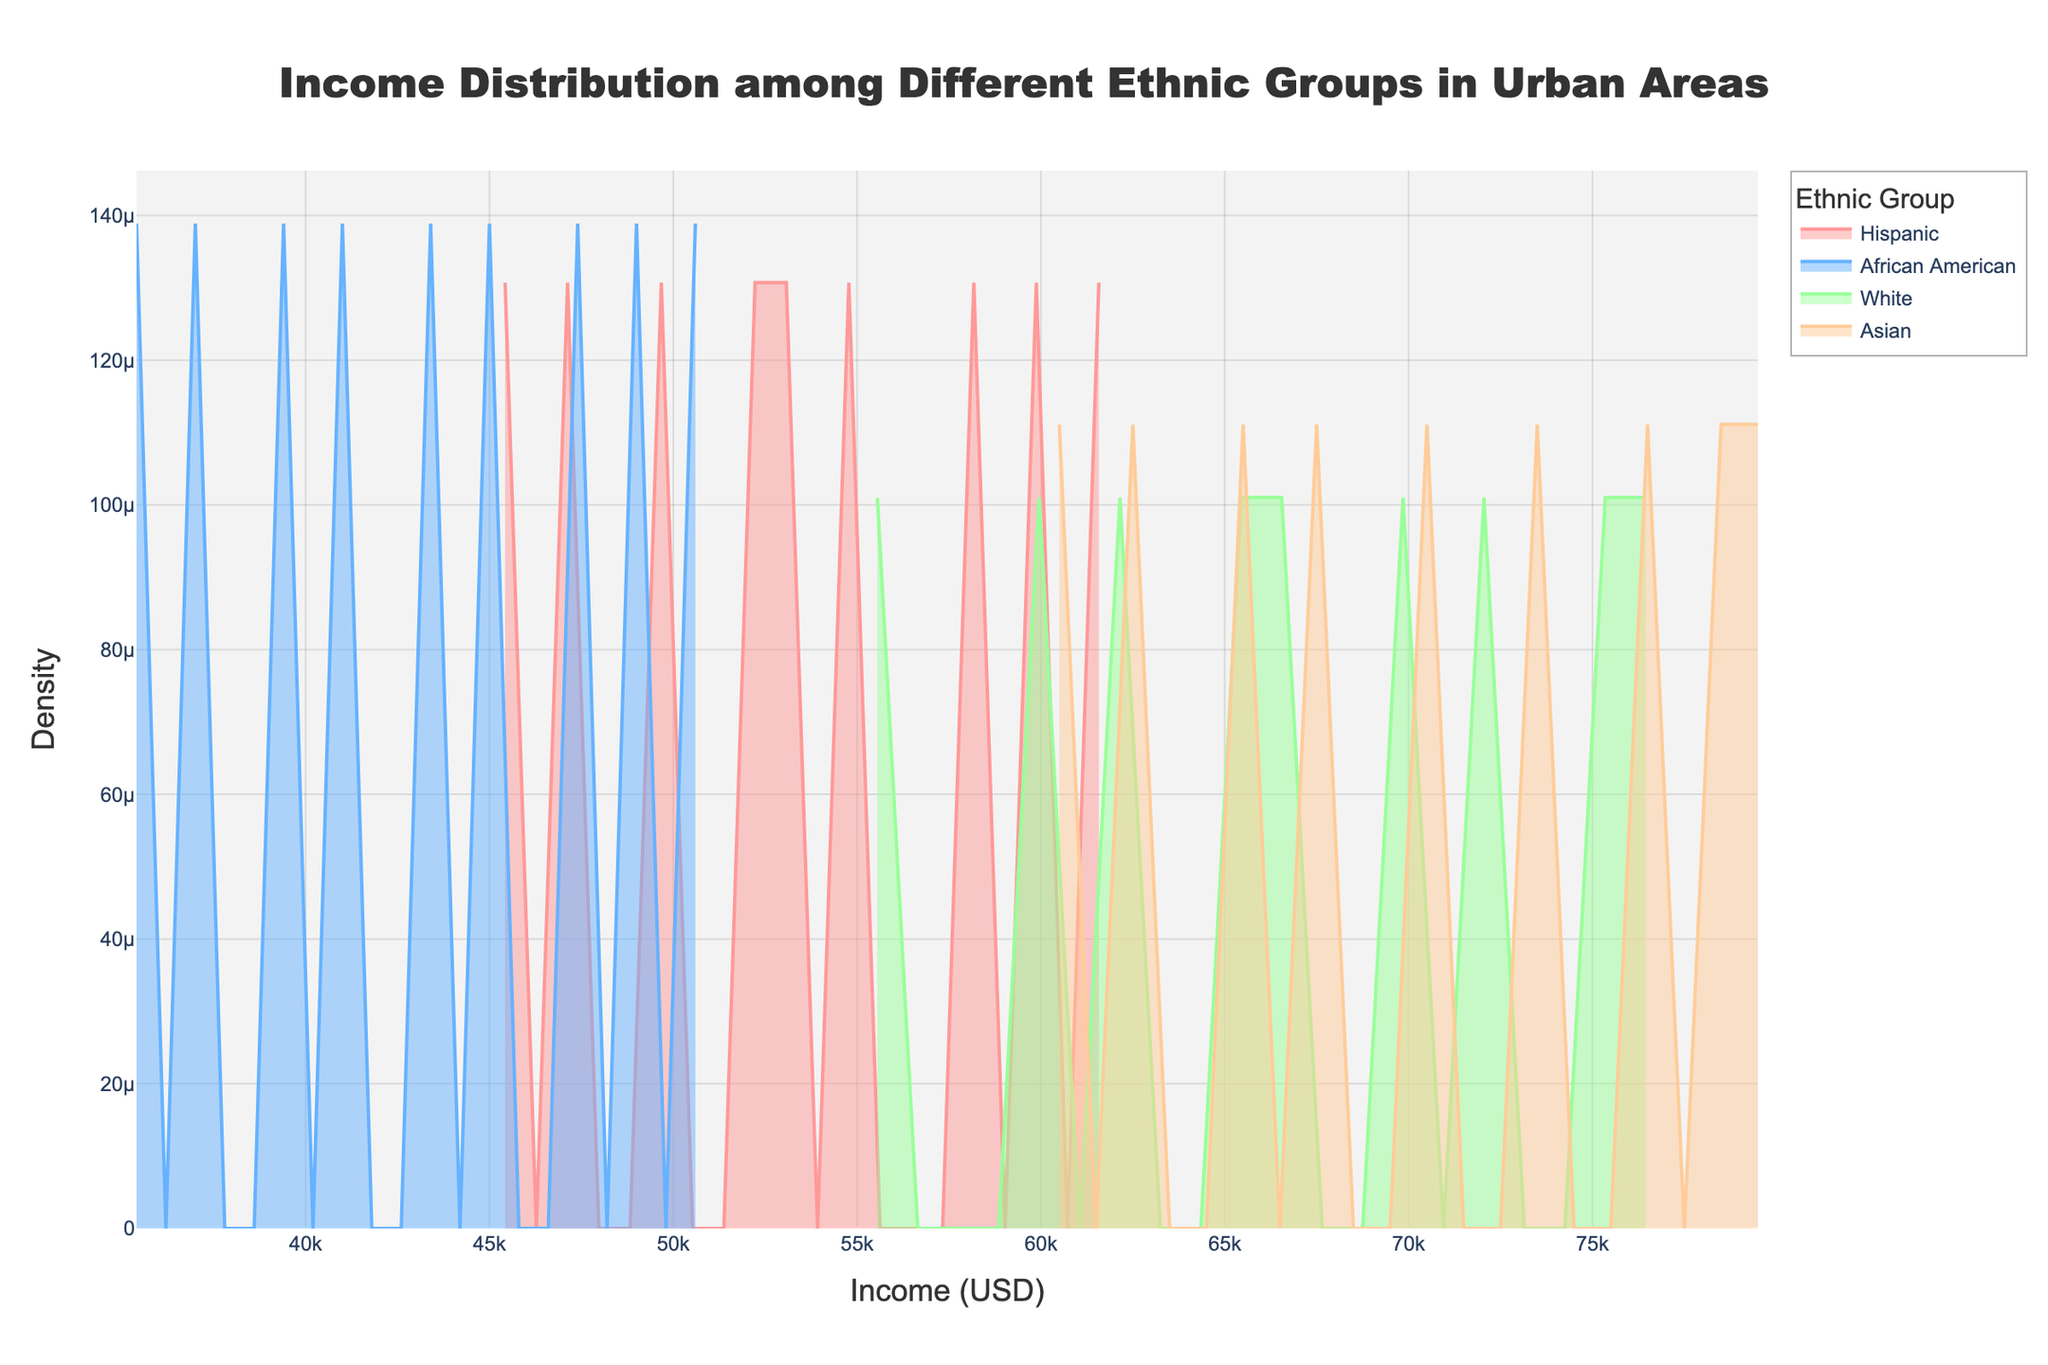What are the colors used to represent each ethnic group? The colors used in the plot are different for each ethnic group. Hispanic is represented by a light red color, African American by a light blue, White by a light green, and Asian by a light orange.
Answer: Hispanic is light red, African American is light blue, White is light green, Asian is light orange What is the title of the plot? The title of the plot is displayed at the top center in a large font. It reads "Income Distribution among Different Ethnic Groups in Urban Areas," providing a succinct summary of what the plot represents.
Answer: Income Distribution among Different Ethnic Groups in Urban Areas Which ethnic group shows the highest peak in income density? By observing the heights of the density curves, the group with the highest peak can be identified. The White and Asian groups both have high peaks, but the White group's peak is slightly taller, indicating a higher density at a specific income range.
Answer: White Which ethnic group has the widest spread of income levels? The width of each density curve indicates the spread of income levels for each ethnic group. The Asian group's curve is the most spread out, suggesting that incomes in this group vary over a broader range.
Answer: Asian What is the range of the x-axis, representing income levels? The x-axis range can be found by looking at the axis's start and end points. It starts from just before $30,000 and extends to around $90,000, covering a wide range of income levels.
Answer: $30,000 to $90,000 Among the ethnic groups, which one has the highest density at approximately $60,000 income level? By locating $60,000 on the x-axis and observing the corresponding heights of each density curve, it's clear that the Asian group's density is the highest around this income level.
Answer: Asian Is the density curve for African American generally higher or lower compared to others? The African American group's density curve is consistently lower than those of the other ethnic groups, indicating a generally lower concentration of incomes within any specific range.
Answer: Lower How does the income density for Hispanic group compare to that for White group around $55,000 to $65,000 income range? Looking at the density curves in the $55,000 to $65,000 range, the density values for White appear higher compared to those for Hispanic, which indicates a higher concentration of White individuals earning within this range.
Answer: White group has higher density What income level roughly corresponds to the highest density for the Hispanic group? By identifying the peak of the density curve for the Hispanic group, which is the highest point on their curve, it appears around the $58,000 to $60,000 income level.
Answer: $58,000 to $60,000 Which ethnic group's income distribution appears more normally distributed? By observing the shape of each curve, the Normal distribution is characterized by a symmetrical bell shape. The White and Asian groups have curves closest to this shape, but the White group's curve is more centered and symmetrical, indicating a more normal distribution.
Answer: White 